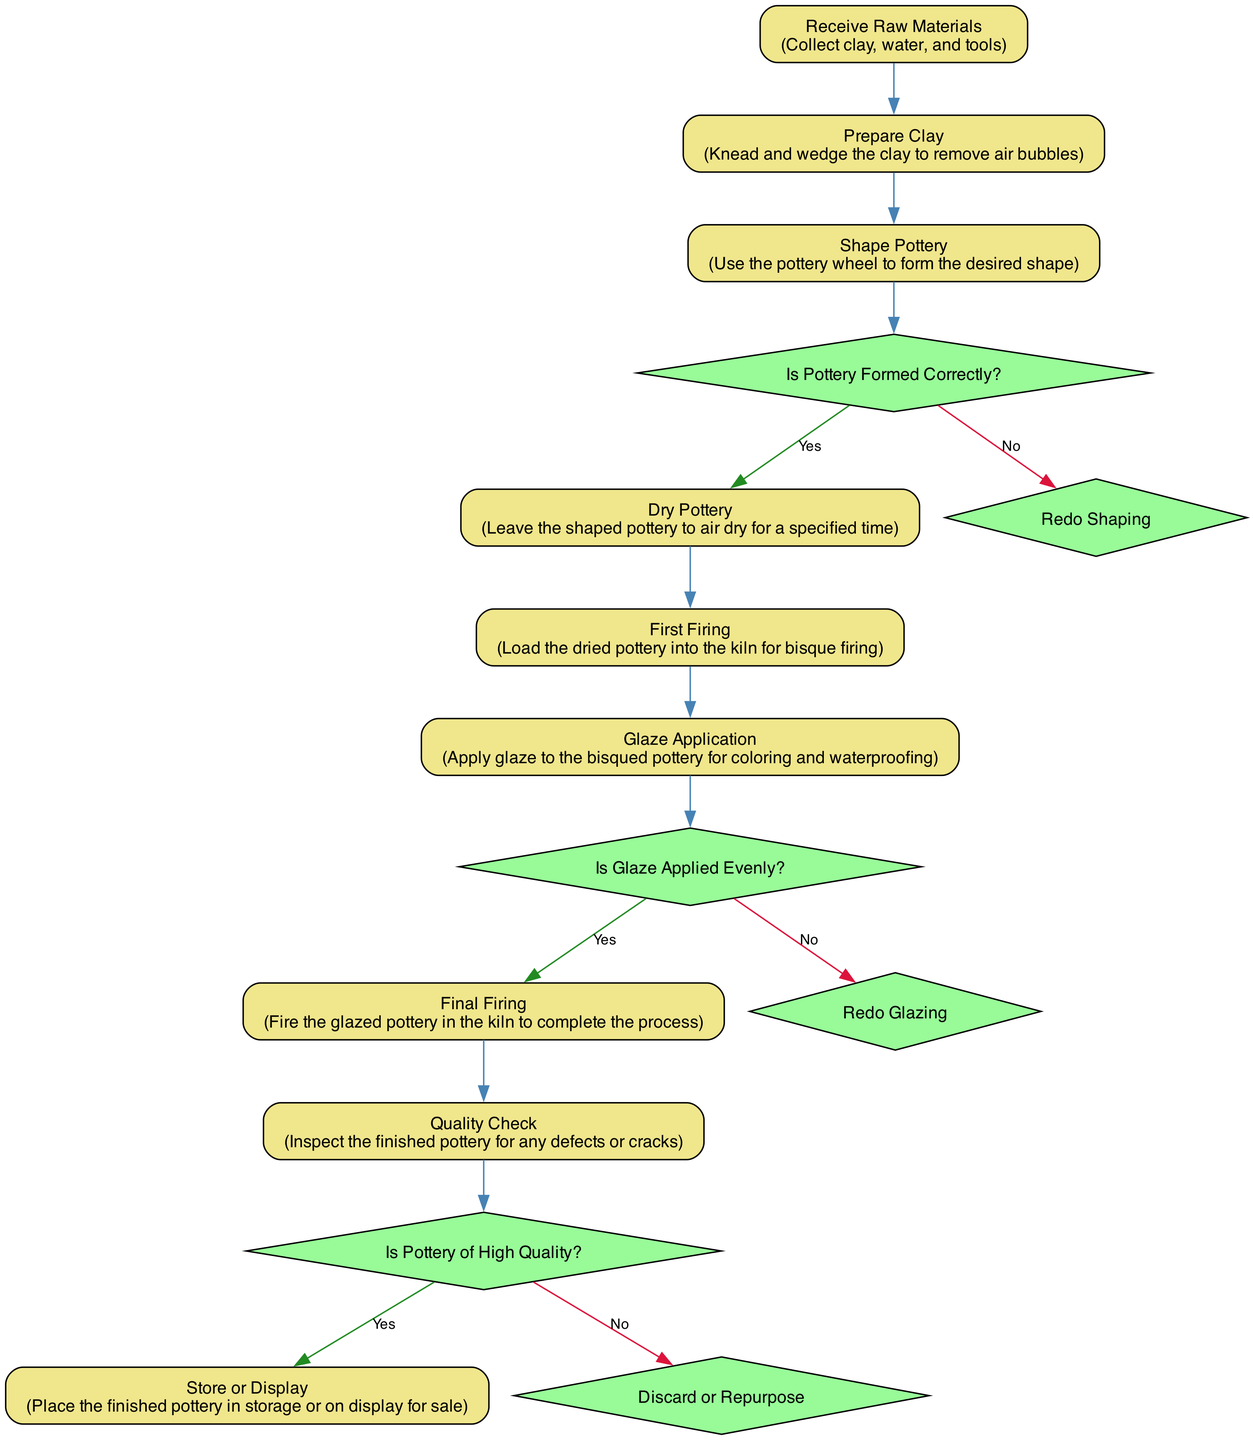What is the first activity in the pottery workshop workflow? The diagram shows that the first activity is "Receive Raw Materials," as it is the starting point in the flow.
Answer: Receive Raw Materials What decision follows the "Shape Pottery" activity? According to the flow in the diagram, the decision node that follows "Shape Pottery" is "Is Pottery Formed Correctly?" which directly assesses the outcome of the shaping process.
Answer: Is Pottery Formed Correctly? How many activities are in the diagram? By counting the listed activities in the diagram, there are a total of 9 activities that describe the steps in the pottery workshop workflow.
Answer: 9 What is the outcome if the answer to "Is Glaze Applied Evenly?" is no? The diagram indicates that if the answer is "No," the workflow leads to "Redo Glazing," which means the process requires revisiting the glazing step.
Answer: Redo Glazing What is the last activity before the pottery is stored or displayed? The flow details that the last activity before "Store or Display" is "Quality Check," which is the final inspection step before determining how to handle the completed pottery.
Answer: Quality Check What activity occurs after "Final Firing"? According to the diagram, the activity that follows "Final Firing" is "Quality Check," which evaluates the quality of the pottery after it has been fired.
Answer: Quality Check What decision needs to be made after the "Quality Check" activity? Following the "Quality Check," the next decision that must be made is "Is Pottery of High Quality?", which determines the final outcome based on the quality inspection.
Answer: Is Pottery of High Quality? If the pottery is deemed high quality, what is the next step in the workflow? The diagram specifies that if pottery is considered high quality after "Quality Check," the next step is to "Store or Display" the finished products.
Answer: Store or Display What follows the "First Firing" in the workflow? The sequence in the diagram shows that "Glaze Application" is the activity that comes after "First Firing," indicating the next step in preparing the pottery.
Answer: Glaze Application 